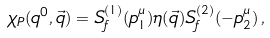Convert formula to latex. <formula><loc_0><loc_0><loc_500><loc_500>\chi _ { P } ( q ^ { 0 } , \vec { q } ) = S _ { f } ^ { ( 1 ) } ( p ^ { \mu } _ { 1 } ) \eta ( \vec { q } ) S _ { f } ^ { ( 2 ) } ( - p ^ { \mu } _ { 2 } ) \, ,</formula> 